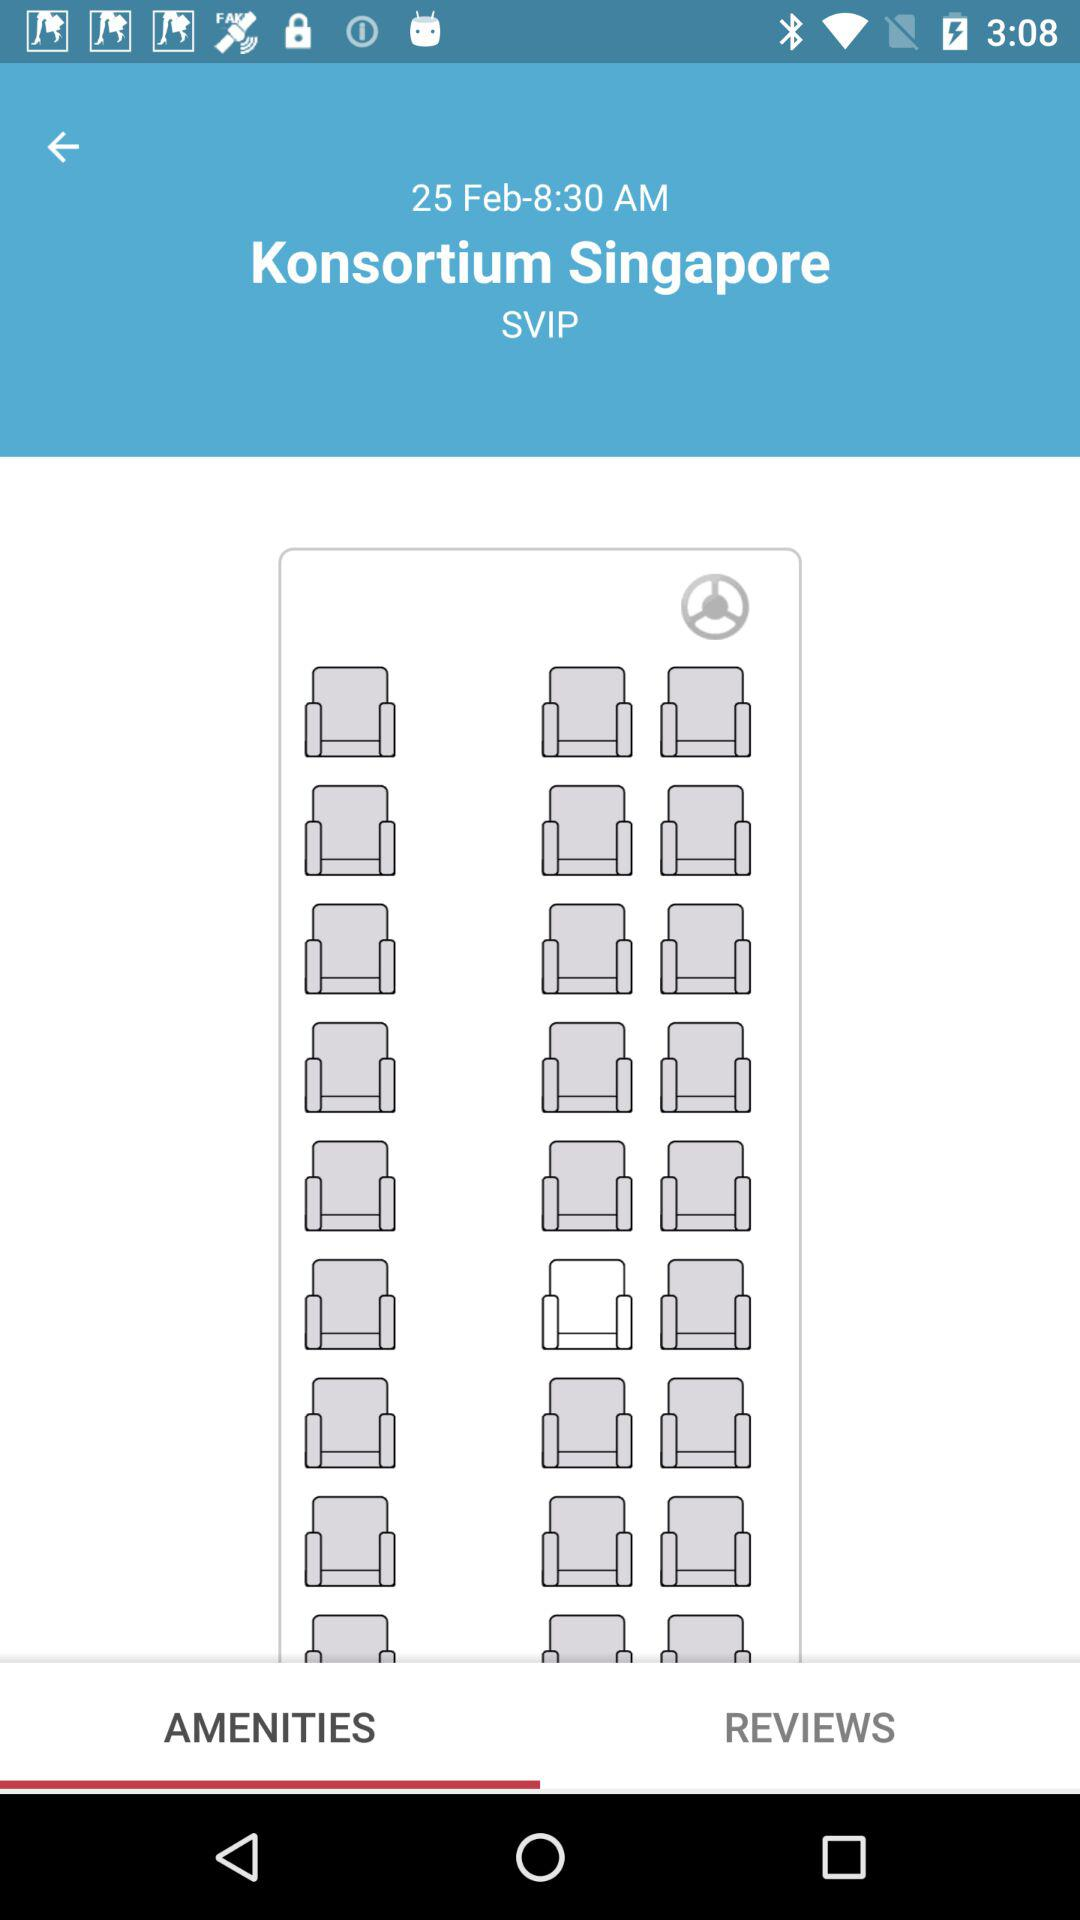What is the time? The time is 8:30 AM. 